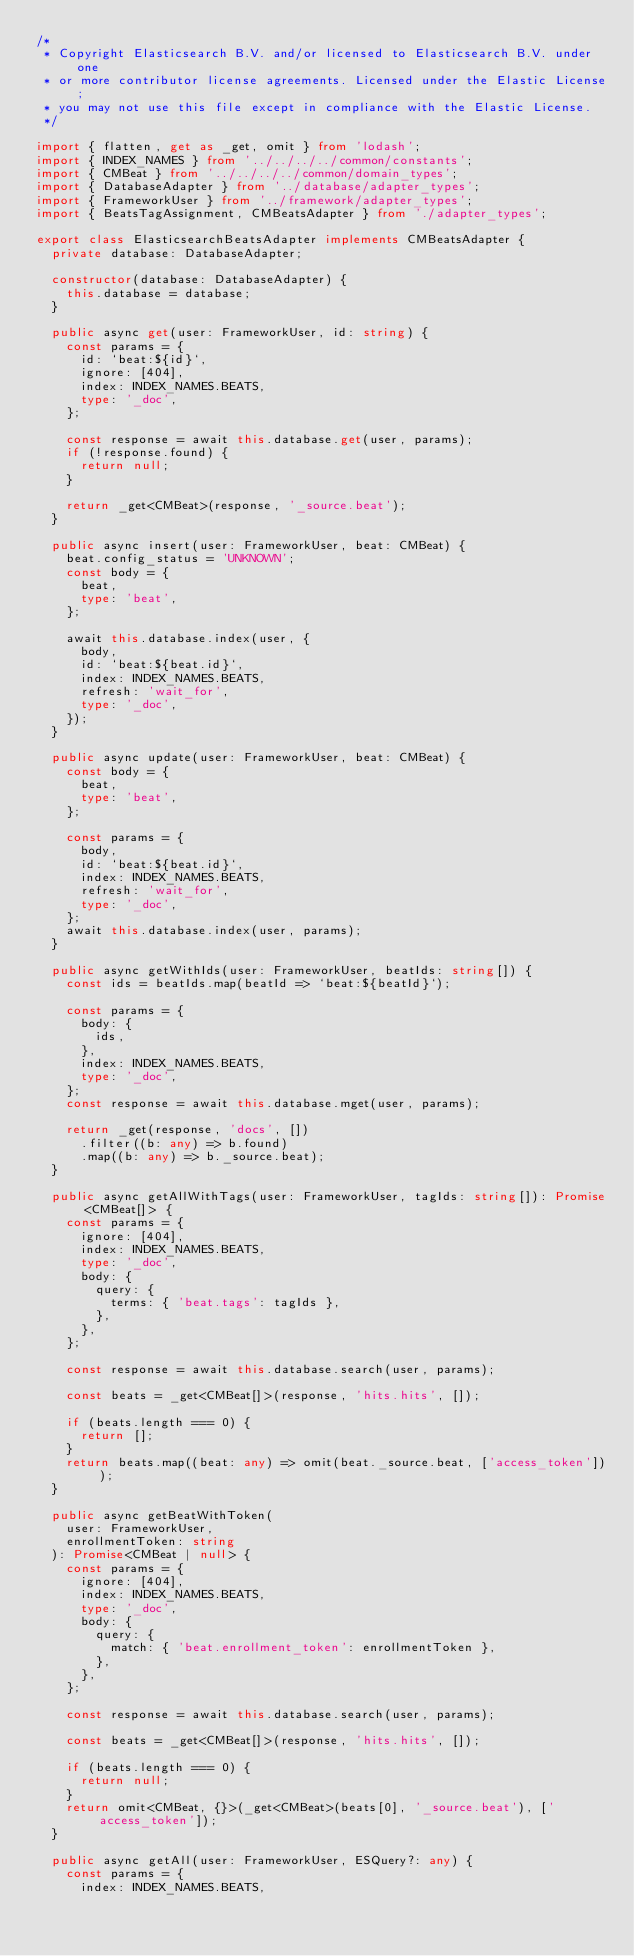Convert code to text. <code><loc_0><loc_0><loc_500><loc_500><_TypeScript_>/*
 * Copyright Elasticsearch B.V. and/or licensed to Elasticsearch B.V. under one
 * or more contributor license agreements. Licensed under the Elastic License;
 * you may not use this file except in compliance with the Elastic License.
 */

import { flatten, get as _get, omit } from 'lodash';
import { INDEX_NAMES } from '../../../../common/constants';
import { CMBeat } from '../../../../common/domain_types';
import { DatabaseAdapter } from '../database/adapter_types';
import { FrameworkUser } from '../framework/adapter_types';
import { BeatsTagAssignment, CMBeatsAdapter } from './adapter_types';

export class ElasticsearchBeatsAdapter implements CMBeatsAdapter {
  private database: DatabaseAdapter;

  constructor(database: DatabaseAdapter) {
    this.database = database;
  }

  public async get(user: FrameworkUser, id: string) {
    const params = {
      id: `beat:${id}`,
      ignore: [404],
      index: INDEX_NAMES.BEATS,
      type: '_doc',
    };

    const response = await this.database.get(user, params);
    if (!response.found) {
      return null;
    }

    return _get<CMBeat>(response, '_source.beat');
  }

  public async insert(user: FrameworkUser, beat: CMBeat) {
    beat.config_status = 'UNKNOWN';
    const body = {
      beat,
      type: 'beat',
    };

    await this.database.index(user, {
      body,
      id: `beat:${beat.id}`,
      index: INDEX_NAMES.BEATS,
      refresh: 'wait_for',
      type: '_doc',
    });
  }

  public async update(user: FrameworkUser, beat: CMBeat) {
    const body = {
      beat,
      type: 'beat',
    };

    const params = {
      body,
      id: `beat:${beat.id}`,
      index: INDEX_NAMES.BEATS,
      refresh: 'wait_for',
      type: '_doc',
    };
    await this.database.index(user, params);
  }

  public async getWithIds(user: FrameworkUser, beatIds: string[]) {
    const ids = beatIds.map(beatId => `beat:${beatId}`);

    const params = {
      body: {
        ids,
      },
      index: INDEX_NAMES.BEATS,
      type: '_doc',
    };
    const response = await this.database.mget(user, params);

    return _get(response, 'docs', [])
      .filter((b: any) => b.found)
      .map((b: any) => b._source.beat);
  }

  public async getAllWithTags(user: FrameworkUser, tagIds: string[]): Promise<CMBeat[]> {
    const params = {
      ignore: [404],
      index: INDEX_NAMES.BEATS,
      type: '_doc',
      body: {
        query: {
          terms: { 'beat.tags': tagIds },
        },
      },
    };

    const response = await this.database.search(user, params);

    const beats = _get<CMBeat[]>(response, 'hits.hits', []);

    if (beats.length === 0) {
      return [];
    }
    return beats.map((beat: any) => omit(beat._source.beat, ['access_token']));
  }

  public async getBeatWithToken(
    user: FrameworkUser,
    enrollmentToken: string
  ): Promise<CMBeat | null> {
    const params = {
      ignore: [404],
      index: INDEX_NAMES.BEATS,
      type: '_doc',
      body: {
        query: {
          match: { 'beat.enrollment_token': enrollmentToken },
        },
      },
    };

    const response = await this.database.search(user, params);

    const beats = _get<CMBeat[]>(response, 'hits.hits', []);

    if (beats.length === 0) {
      return null;
    }
    return omit<CMBeat, {}>(_get<CMBeat>(beats[0], '_source.beat'), ['access_token']);
  }

  public async getAll(user: FrameworkUser, ESQuery?: any) {
    const params = {
      index: INDEX_NAMES.BEATS,</code> 